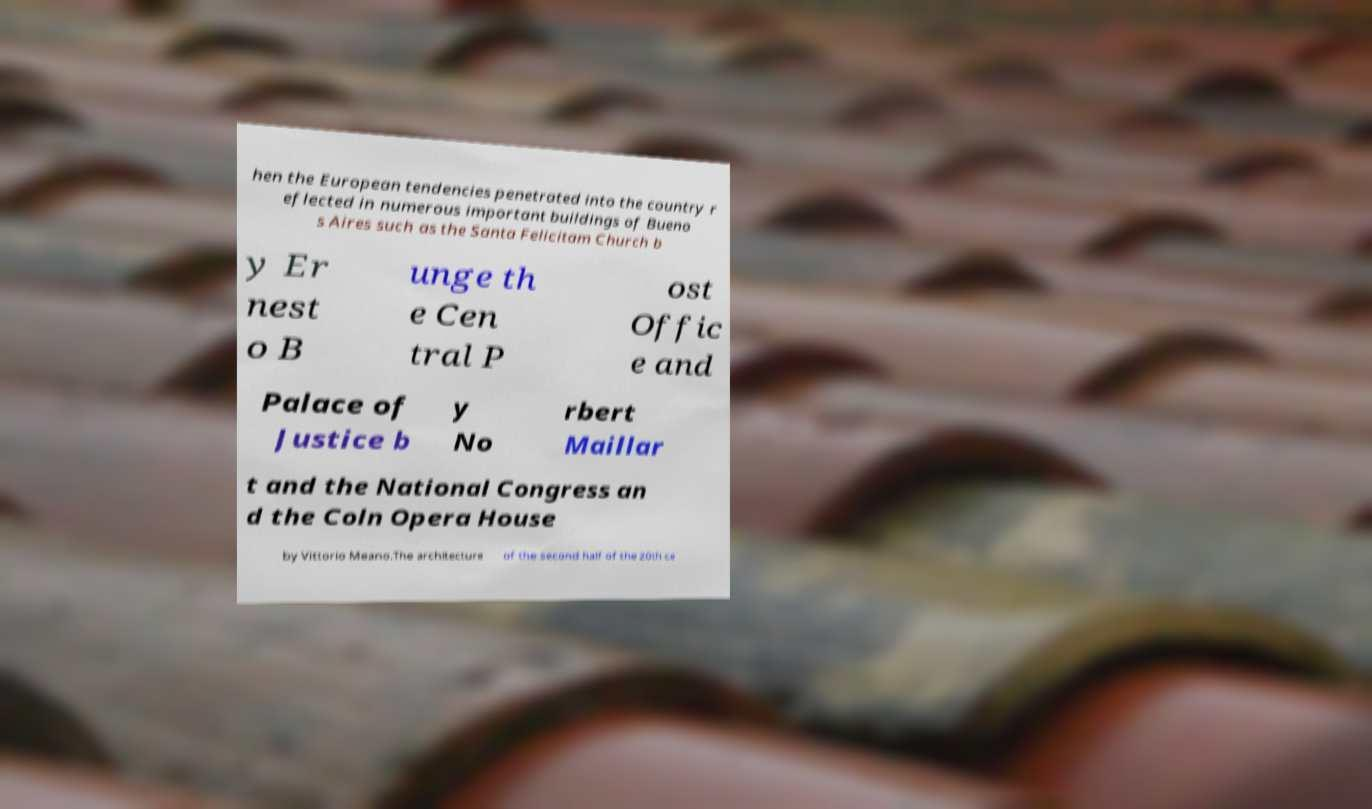Could you assist in decoding the text presented in this image and type it out clearly? hen the European tendencies penetrated into the country r eflected in numerous important buildings of Bueno s Aires such as the Santa Felicitam Church b y Er nest o B unge th e Cen tral P ost Offic e and Palace of Justice b y No rbert Maillar t and the National Congress an d the Coln Opera House by Vittorio Meano.The architecture of the second half of the 20th ce 